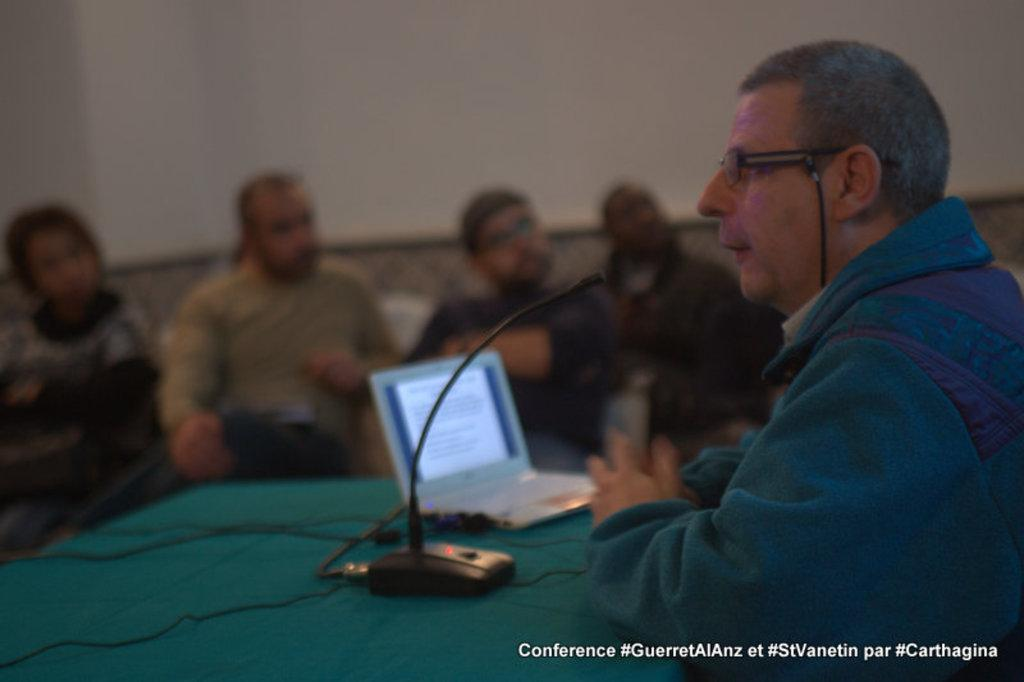What are the people in the image doing? The people in the image are sitting. What is located at the bottom of the image? There is a table at the bottom of the image. What electronic device is on the table? A laptop is present on the table. What is the purpose of the object placed next to the laptop? A mic is placed on the table, which might be used for recording or amplifying sound. What can be seen in the background of the image? There is a wall in the background of the image. What type of stitch is being used to sew the book in the image? There is no book or stitching present in the image. How long is the trail visible in the image? There is no trail visible in the image. 